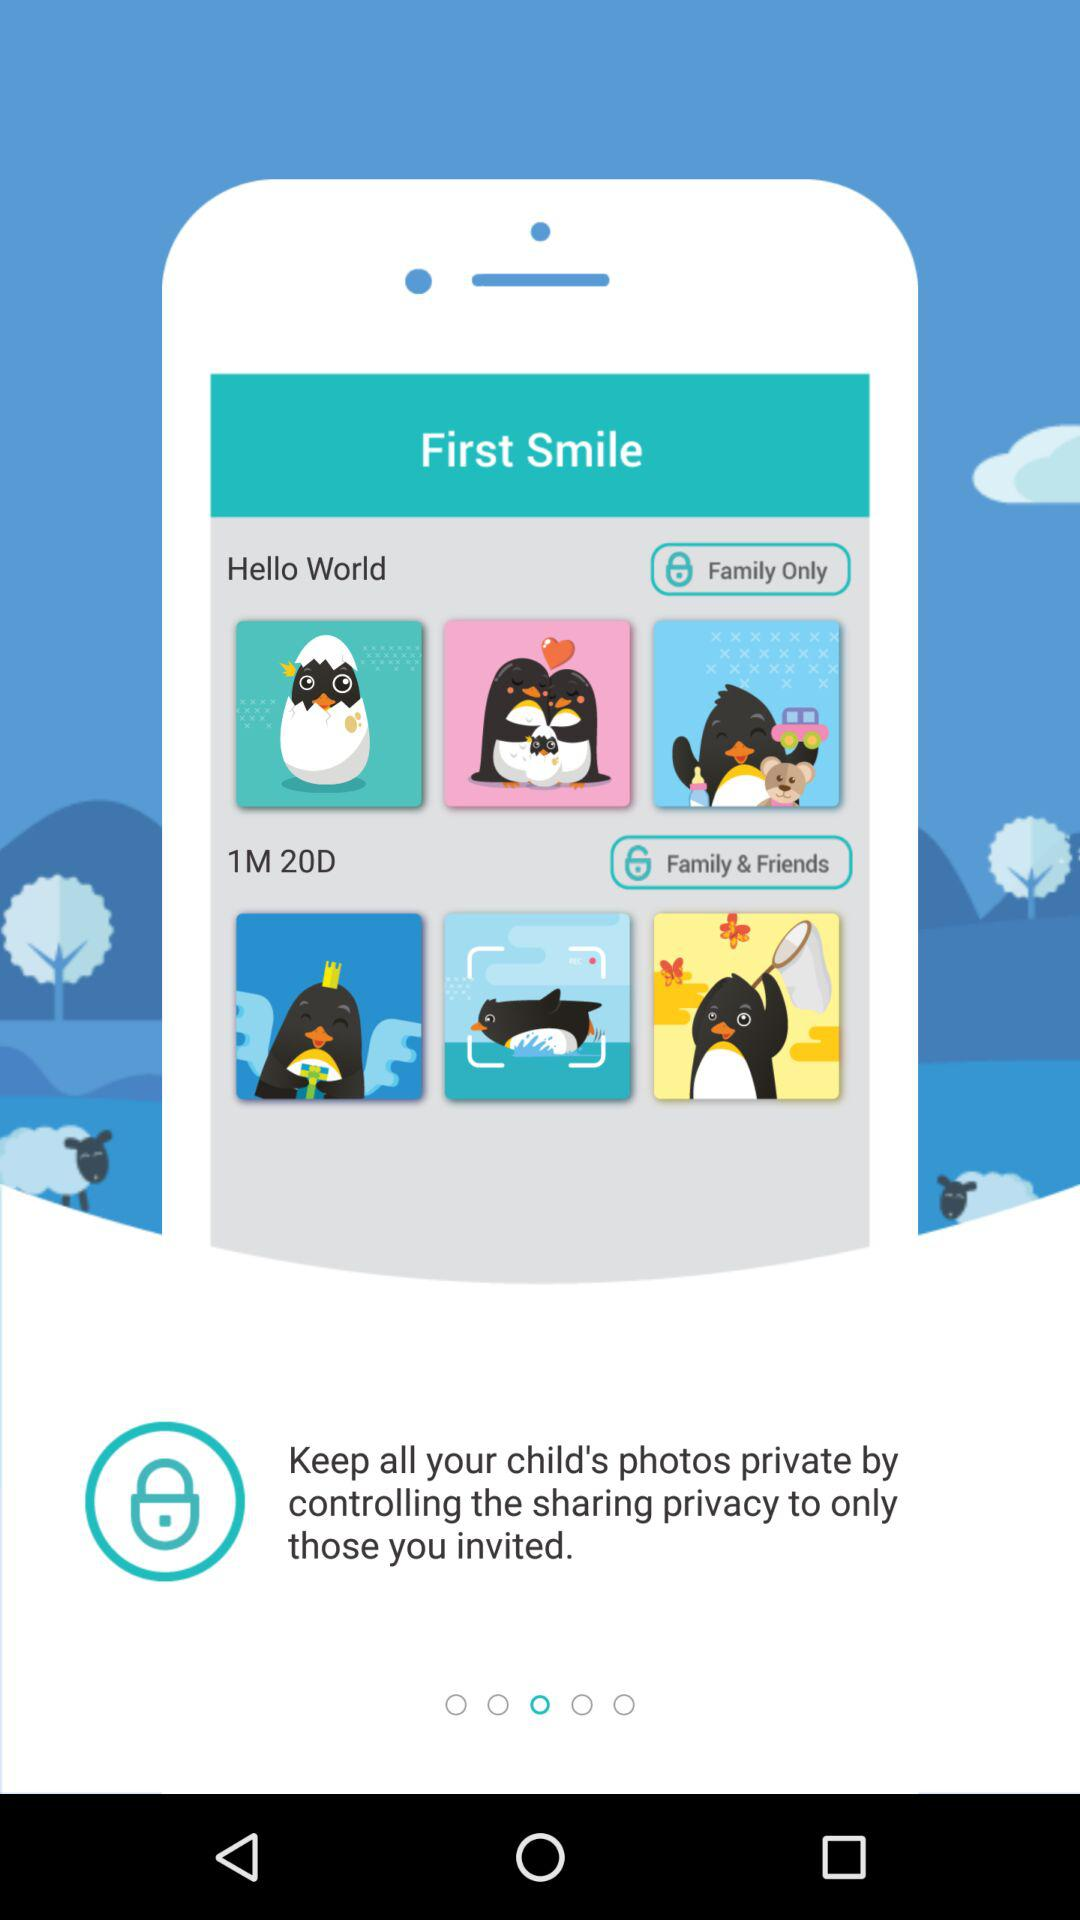What is the application name? The application name is "First Smile". 